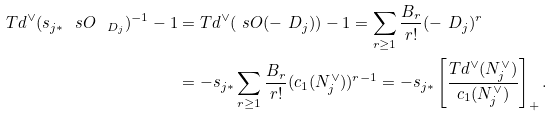<formula> <loc_0><loc_0><loc_500><loc_500>T d ^ { \vee } ( s _ { j * } \ s O _ { \ D _ { j } } ) ^ { - 1 } - 1 & = T d ^ { \vee } ( \ s O ( - \ D _ { j } ) ) - 1 = \sum _ { r \geq 1 } \frac { B _ { r } } { r ! } ( - \ D _ { j } ) ^ { r } \\ & = - s _ { j * } \sum _ { r \geq 1 } \frac { B _ { r } } { r ! } ( c _ { 1 } ( N _ { j } ^ { \vee } ) ) ^ { r - 1 } = - s _ { j * } \left [ \frac { T d ^ { \vee } ( N _ { j } ^ { \vee } ) } { c _ { 1 } ( N _ { j } ^ { \vee } ) } \right ] _ { + } .</formula> 